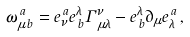Convert formula to latex. <formula><loc_0><loc_0><loc_500><loc_500>\omega _ { \mu \, b } ^ { \, a } = e _ { \nu } ^ { \, a } e _ { \, b } ^ { \lambda } \Gamma _ { \, \mu \lambda } ^ { \nu } - e _ { \, b } ^ { \lambda } \partial _ { \mu } e _ { \lambda } ^ { \, a } \, ,</formula> 